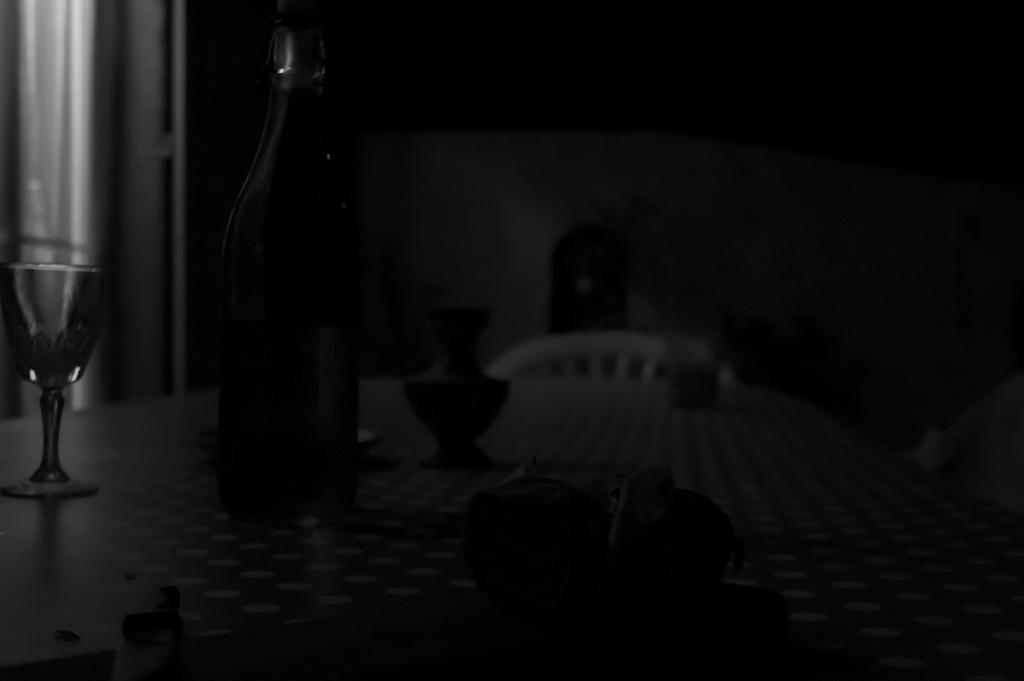What piece of furniture is present in the image? There is a table in the image. What is placed on the table? There is a glass, a bottle, and a vase on the table. What is the purpose of the objects placed on the table? The glass, bottle, and vase are likely used for drinking, holding liquid, and displaying flowers, respectively. What can be seen in the background of the image? There is a chair and a wall in the background of the image. How many mice are visible on the table in the image? There are no mice present on the table in the image. What type of voyage is depicted in the image? There is no voyage depicted in the image; it features a table with various objects on it. 